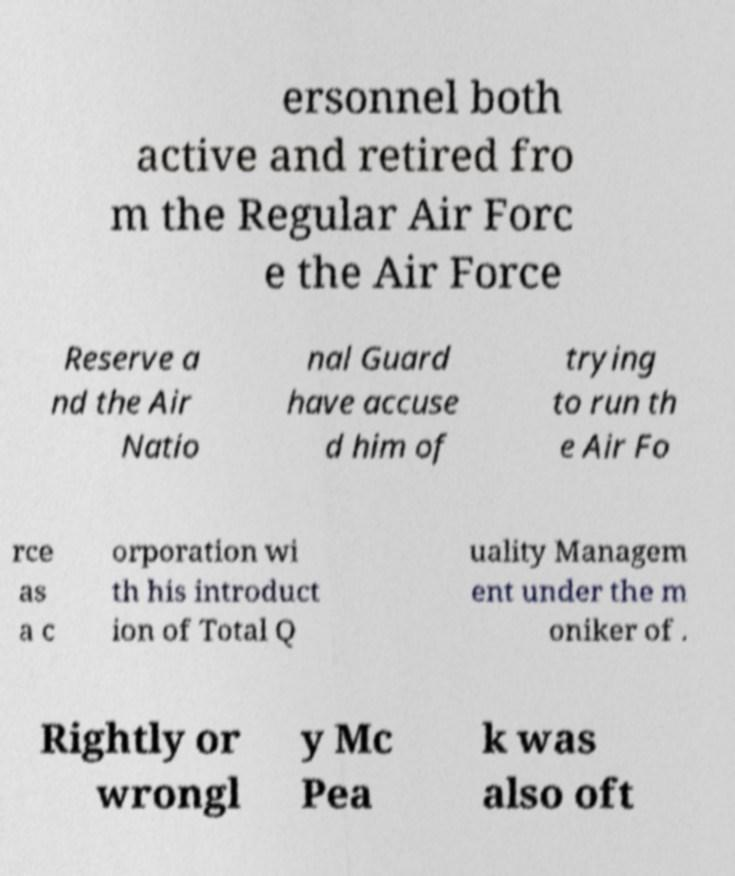Could you assist in decoding the text presented in this image and type it out clearly? ersonnel both active and retired fro m the Regular Air Forc e the Air Force Reserve a nd the Air Natio nal Guard have accuse d him of trying to run th e Air Fo rce as a c orporation wi th his introduct ion of Total Q uality Managem ent under the m oniker of . Rightly or wrongl y Mc Pea k was also oft 